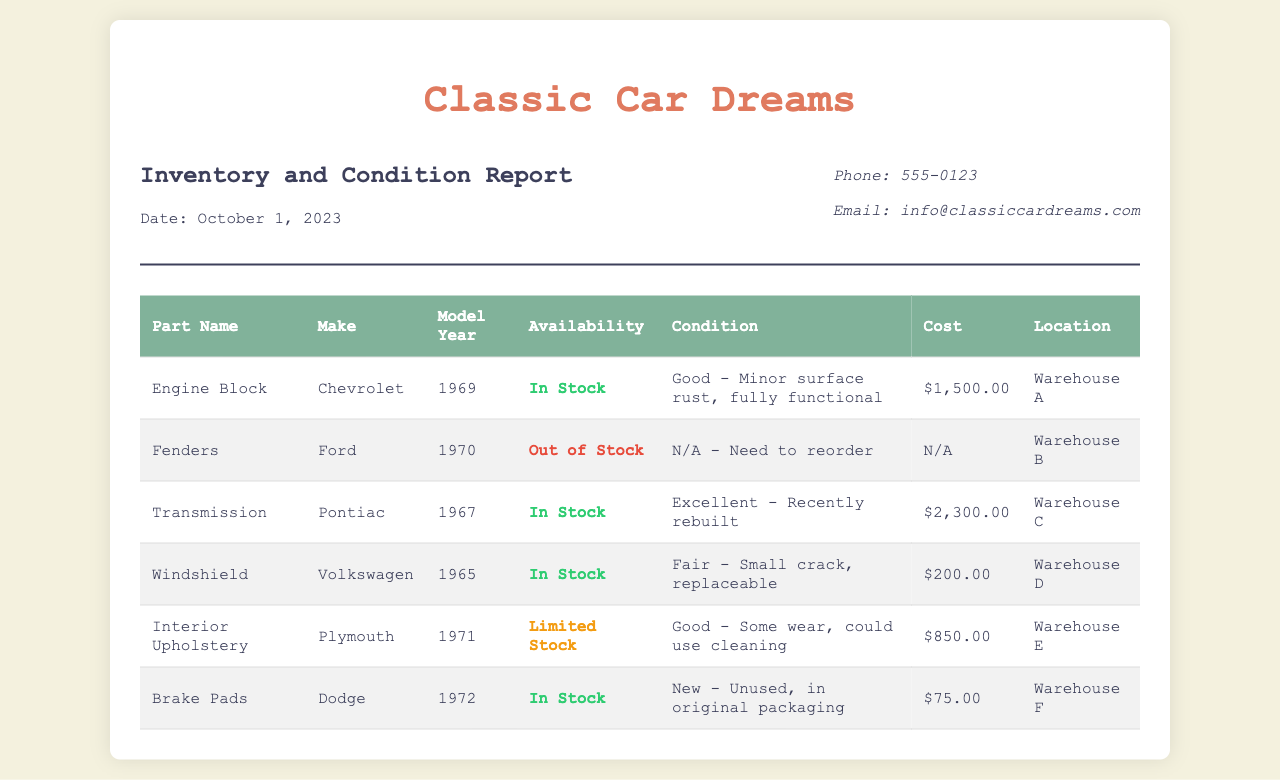what part is in stock and has minor surface rust? The document states that the Engine Block is in stock and has minor surface rust.
Answer: Engine Block what is the cost of the Transmission? The document clearly lists the cost of the Transmission as $2,300.00.
Answer: $2,300.00 which part has a small crack? According to the document, the Windshield has a small crack.
Answer: Windshield how many items are listed as limited stock? The document shows one item listed as limited stock, which is the Interior Upholstery.
Answer: 1 which warehouse contains the Brake Pads? The document indicates that the Brake Pads are located in Warehouse F.
Answer: Warehouse F what is the model year of the Fenders? The document specifies that the model year of the Fenders is 1970.
Answer: 1970 what is the condition of the Interior Upholstery? The document describes the condition of the Interior Upholstery as good with some wear.
Answer: Good - some wear which car make does the Engine Block belong to? The document states that the Engine Block belongs to Chevrolet.
Answer: Chevrolet what is the total cost of all parts available in stock? By adding the costs of the available parts: $1,500.00 + $2,300.00 + $200.00 + $75.00 = $4,075.00.
Answer: $4,075.00 